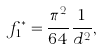<formula> <loc_0><loc_0><loc_500><loc_500>f _ { 1 } ^ { * } = \frac { \pi ^ { 2 } } { 6 4 } \frac { 1 } { d ^ { 2 } } ,</formula> 